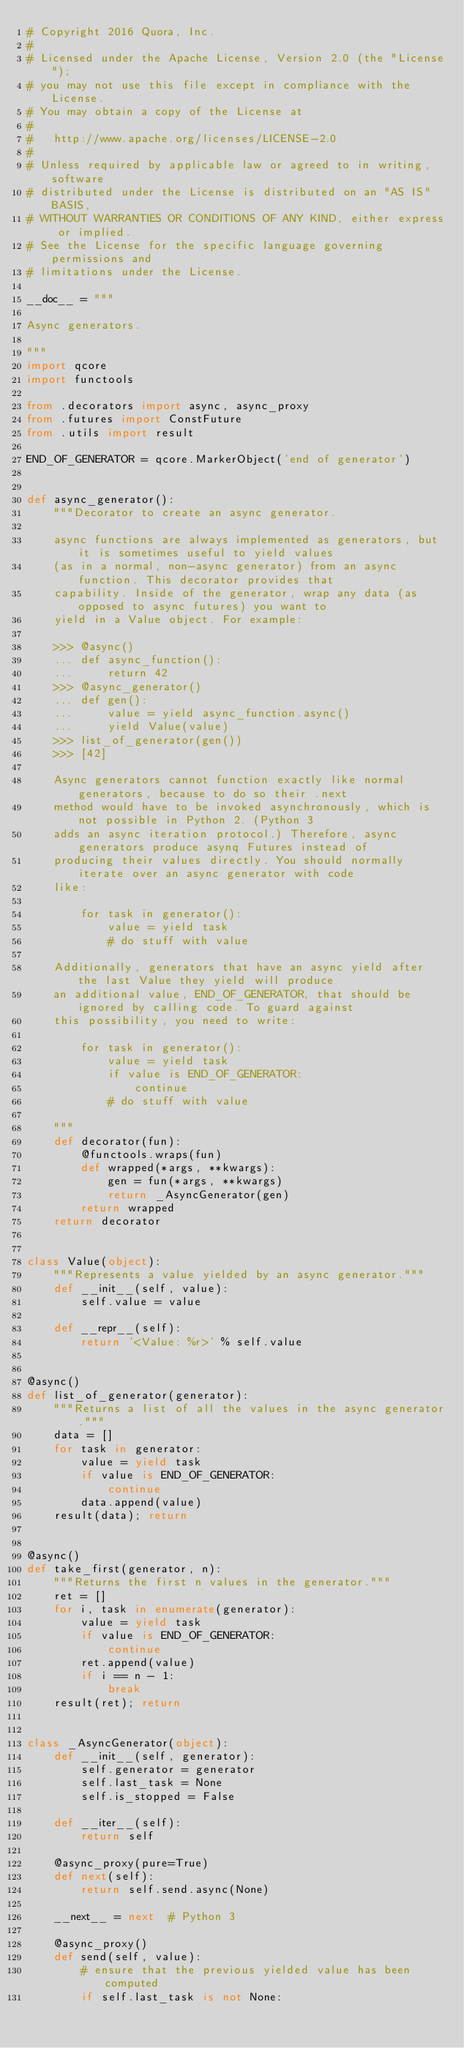<code> <loc_0><loc_0><loc_500><loc_500><_Python_># Copyright 2016 Quora, Inc.
#
# Licensed under the Apache License, Version 2.0 (the "License");
# you may not use this file except in compliance with the License.
# You may obtain a copy of the License at
#
#   http://www.apache.org/licenses/LICENSE-2.0
#
# Unless required by applicable law or agreed to in writing, software
# distributed under the License is distributed on an "AS IS" BASIS,
# WITHOUT WARRANTIES OR CONDITIONS OF ANY KIND, either express or implied.
# See the License for the specific language governing permissions and
# limitations under the License.

__doc__ = """

Async generators.

"""
import qcore
import functools

from .decorators import async, async_proxy
from .futures import ConstFuture
from .utils import result

END_OF_GENERATOR = qcore.MarkerObject('end of generator')


def async_generator():
    """Decorator to create an async generator.

    async functions are always implemented as generators, but it is sometimes useful to yield values
    (as in a normal, non-async generator) from an async function. This decorator provides that
    capability. Inside of the generator, wrap any data (as opposed to async futures) you want to
    yield in a Value object. For example:

    >>> @async()
    ... def async_function():
    ...     return 42
    >>> @async_generator()
    ... def gen():
    ...     value = yield async_function.async()
    ...     yield Value(value)
    >>> list_of_generator(gen())
    >>> [42]

    Async generators cannot function exactly like normal generators, because to do so their .next
    method would have to be invoked asynchronously, which is not possible in Python 2. (Python 3
    adds an async iteration protocol.) Therefore, async generators produce asynq Futures instead of
    producing their values directly. You should normally iterate over an async generator with code
    like:

        for task in generator():
            value = yield task
            # do stuff with value

    Additionally, generators that have an async yield after the last Value they yield will produce
    an additional value, END_OF_GENERATOR, that should be ignored by calling code. To guard against
    this possibility, you need to write:

        for task in generator():
            value = yield task
            if value is END_OF_GENERATOR:
                continue
            # do stuff with value

    """
    def decorator(fun):
        @functools.wraps(fun)
        def wrapped(*args, **kwargs):
            gen = fun(*args, **kwargs)
            return _AsyncGenerator(gen)
        return wrapped
    return decorator


class Value(object):
    """Represents a value yielded by an async generator."""
    def __init__(self, value):
        self.value = value

    def __repr__(self):
        return '<Value: %r>' % self.value


@async()
def list_of_generator(generator):
    """Returns a list of all the values in the async generator."""
    data = []
    for task in generator:
        value = yield task
        if value is END_OF_GENERATOR:
            continue
        data.append(value)
    result(data); return


@async()
def take_first(generator, n):
    """Returns the first n values in the generator."""
    ret = []
    for i, task in enumerate(generator):
        value = yield task
        if value is END_OF_GENERATOR:
            continue
        ret.append(value)
        if i == n - 1:
            break
    result(ret); return


class _AsyncGenerator(object):
    def __init__(self, generator):
        self.generator = generator
        self.last_task = None
        self.is_stopped = False

    def __iter__(self):
        return self

    @async_proxy(pure=True)
    def next(self):
        return self.send.async(None)

    __next__ = next  # Python 3

    @async_proxy()
    def send(self, value):
        # ensure that the previous yielded value has been computed
        if self.last_task is not None:</code> 